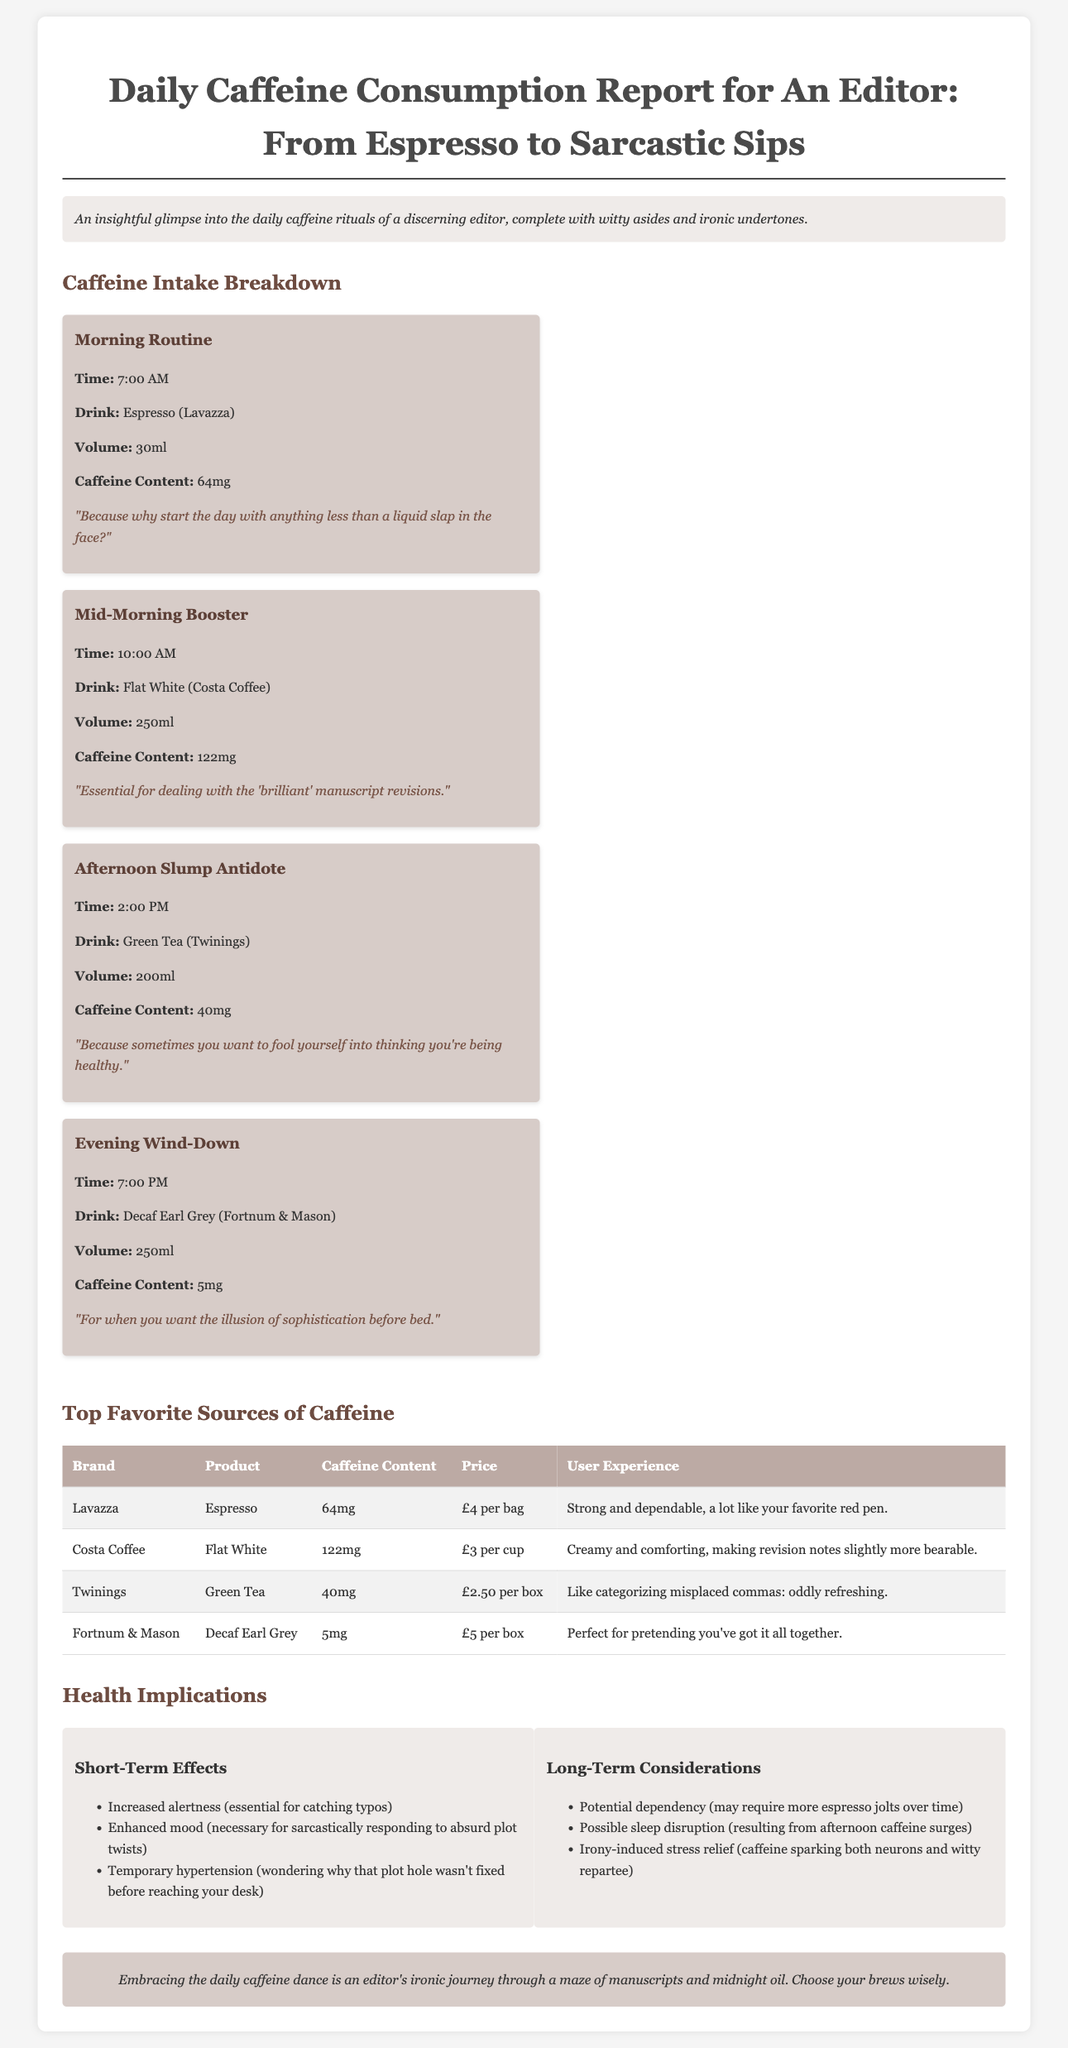What time is the Morning Routine? The Morning Routine is documented as taking place at 7:00 AM.
Answer: 7:00 AM What drink is consumed during the Mid-Morning Booster? The drink consumed during the Mid-Morning Booster is a Flat White from Costa Coffee.
Answer: Flat White How much caffeine is in the Decaf Earl Grey? The caffeine content in the Decaf Earl Grey is noted as 5mg.
Answer: 5mg What is the price of a box of Green Tea? The price of a box of Green Tea is stated as £2.50.
Answer: £2.50 Which brand has the highest caffeine content? The brand with the highest caffeine content is Costa Coffee with 122mg in Flat White.
Answer: Costa Coffee What are the short-term effects of caffeine listed? The short-term effects listed include increased alertness, enhanced mood, and temporary hypertension.
Answer: Increased alertness, enhanced mood, temporary hypertension What is the conclusion about the daily caffeine dance? The conclusion emphasizes the ironic journey through manuscripts and the importance of choosing brews wisely.
Answer: Choose your brews wisely How much caffeine is in the Green Tea? The document specifies that the caffeine content in Green Tea is 40mg.
Answer: 40mg What does the user experience say about Costa Coffee's Flat White? The user experience describes the Flat White as creamy and comforting.
Answer: Creamy and comforting 